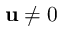<formula> <loc_0><loc_0><loc_500><loc_500>\mathbf u \neq 0</formula> 